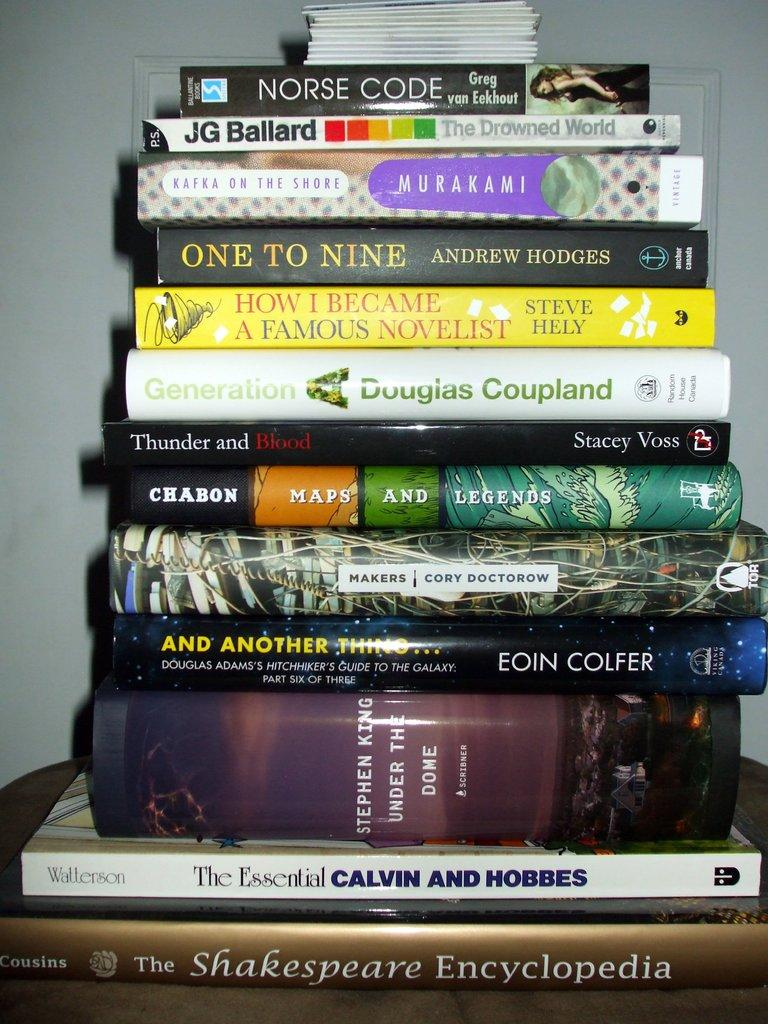<image>
Summarize the visual content of the image. A book titled Norse Code is on top of a stack of books. 